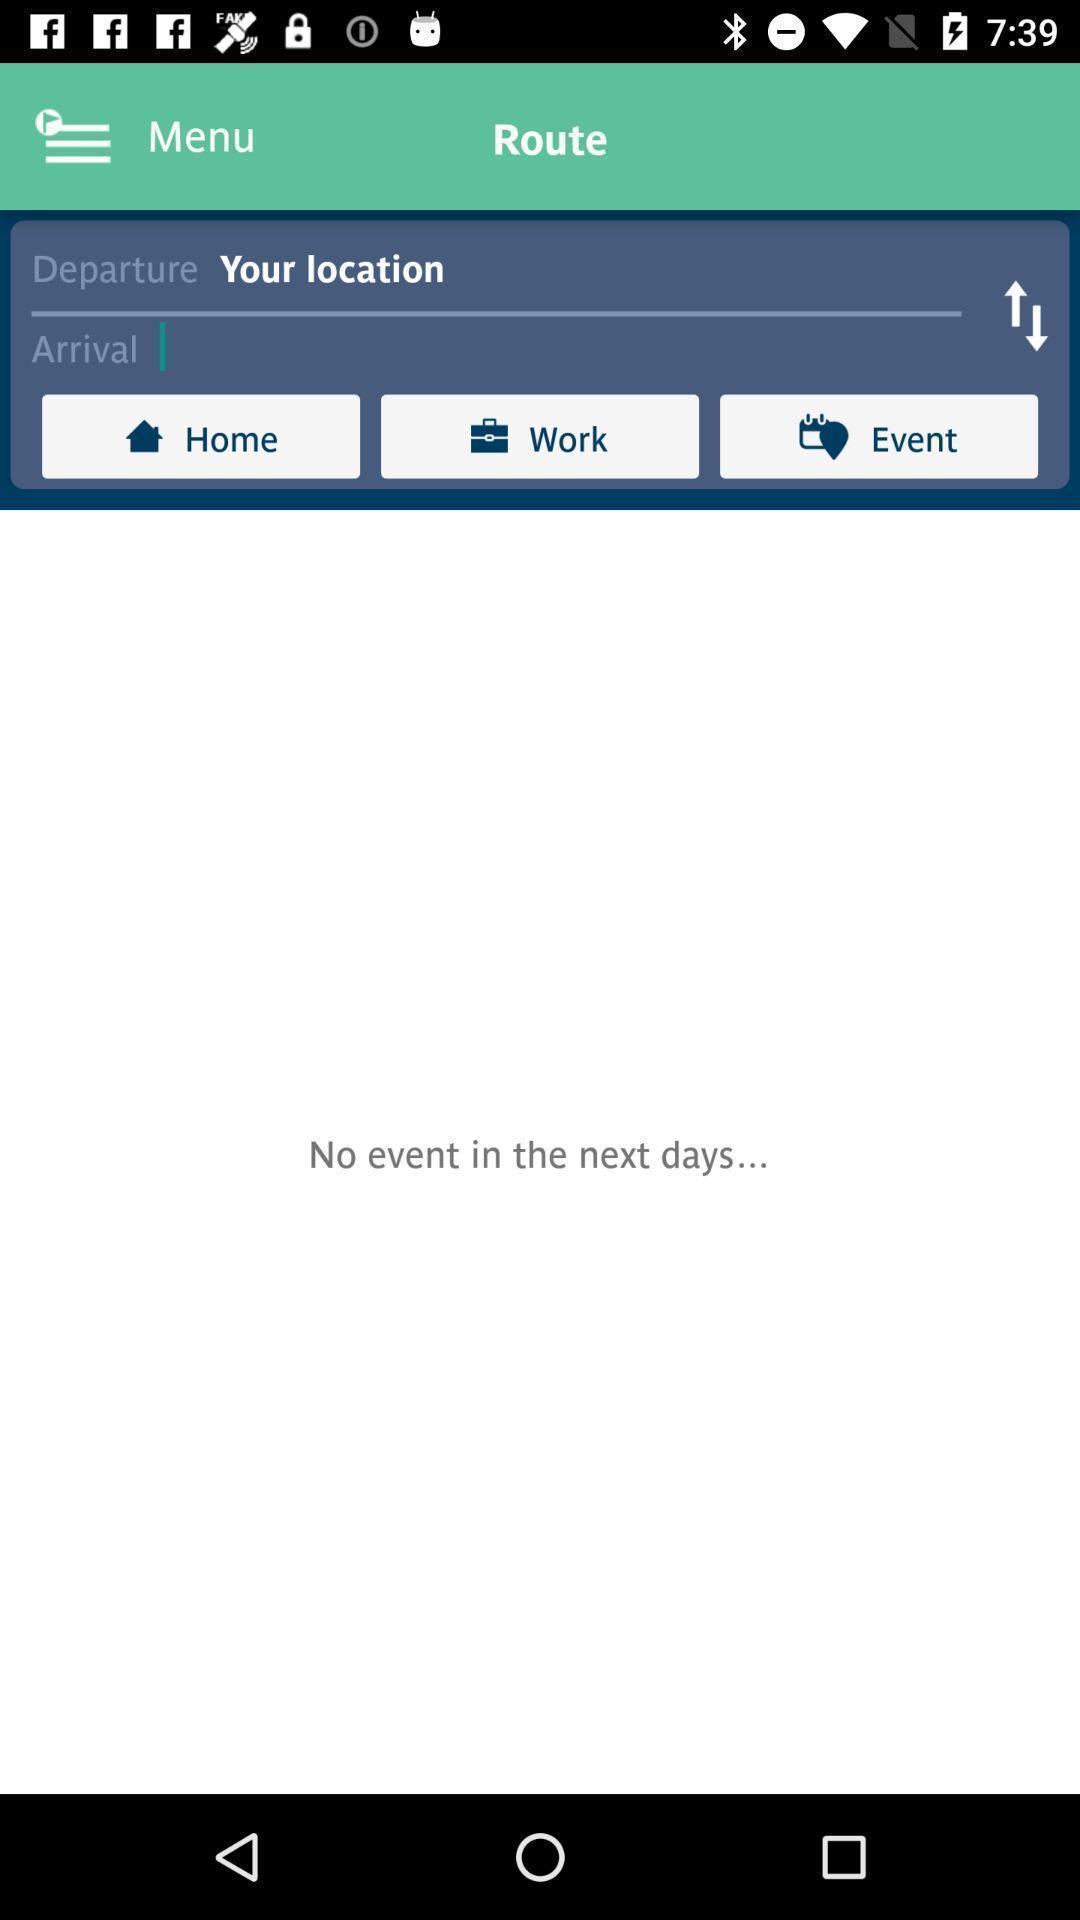Give me a narrative description of this picture. Page showing no event in the next days. 